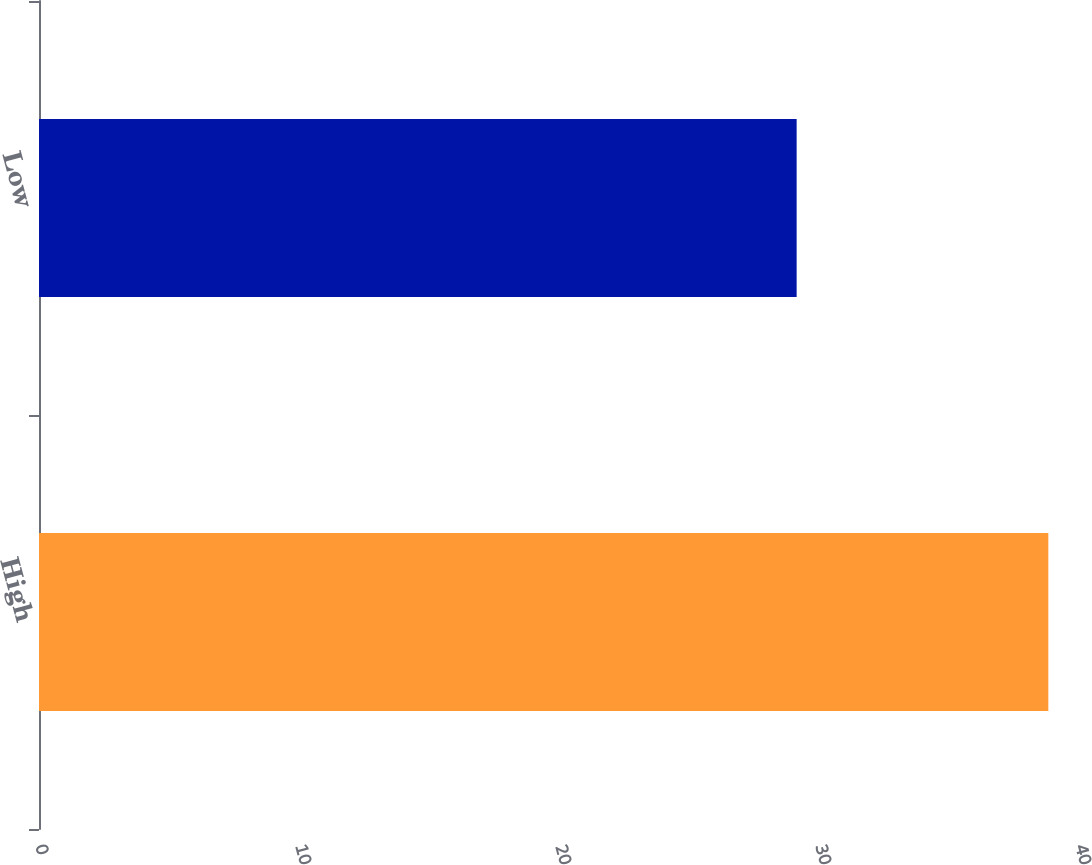Convert chart. <chart><loc_0><loc_0><loc_500><loc_500><bar_chart><fcel>High<fcel>Low<nl><fcel>38.82<fcel>29.14<nl></chart> 